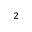<formula> <loc_0><loc_0><loc_500><loc_500>^ { 2 }</formula> 